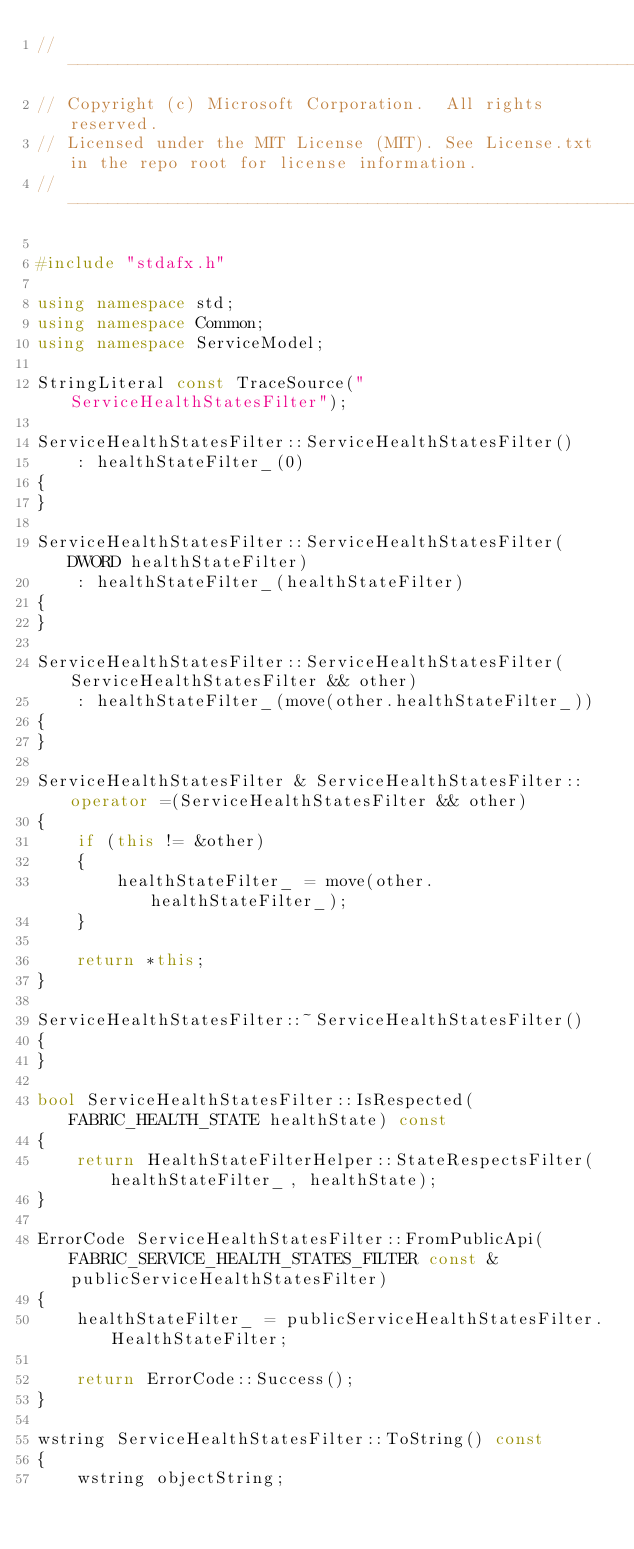<code> <loc_0><loc_0><loc_500><loc_500><_C++_>// ------------------------------------------------------------
// Copyright (c) Microsoft Corporation.  All rights reserved.
// Licensed under the MIT License (MIT). See License.txt in the repo root for license information.
// ------------------------------------------------------------

#include "stdafx.h"

using namespace std;
using namespace Common;
using namespace ServiceModel;

StringLiteral const TraceSource("ServiceHealthStatesFilter");

ServiceHealthStatesFilter::ServiceHealthStatesFilter()
    : healthStateFilter_(0)
{
}

ServiceHealthStatesFilter::ServiceHealthStatesFilter(DWORD healthStateFilter)
    : healthStateFilter_(healthStateFilter)
{
}

ServiceHealthStatesFilter::ServiceHealthStatesFilter(ServiceHealthStatesFilter && other)
    : healthStateFilter_(move(other.healthStateFilter_))
{
}

ServiceHealthStatesFilter & ServiceHealthStatesFilter::operator =(ServiceHealthStatesFilter && other)
{
    if (this != &other)
    {
        healthStateFilter_ = move(other.healthStateFilter_);
    }

    return *this;
}

ServiceHealthStatesFilter::~ServiceHealthStatesFilter()
{
}

bool ServiceHealthStatesFilter::IsRespected(FABRIC_HEALTH_STATE healthState) const
{
    return HealthStateFilterHelper::StateRespectsFilter(healthStateFilter_, healthState);
}

ErrorCode ServiceHealthStatesFilter::FromPublicApi(FABRIC_SERVICE_HEALTH_STATES_FILTER const & publicServiceHealthStatesFilter)
{
    healthStateFilter_ = publicServiceHealthStatesFilter.HealthStateFilter;

    return ErrorCode::Success();
}

wstring ServiceHealthStatesFilter::ToString() const
{
    wstring objectString;</code> 